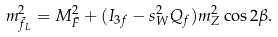<formula> <loc_0><loc_0><loc_500><loc_500>m _ { \tilde { f } _ { L } } ^ { 2 } = M _ { \tilde { F } } ^ { 2 } + ( I _ { 3 f } - s _ { W } ^ { 2 } Q _ { f } ) m _ { Z } ^ { 2 } \cos 2 \beta .</formula> 